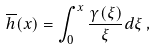Convert formula to latex. <formula><loc_0><loc_0><loc_500><loc_500>\overline { h } ( x ) = \int ^ { x } _ { 0 } \frac { \gamma ( \xi ) } { \xi } d \xi \, ,</formula> 